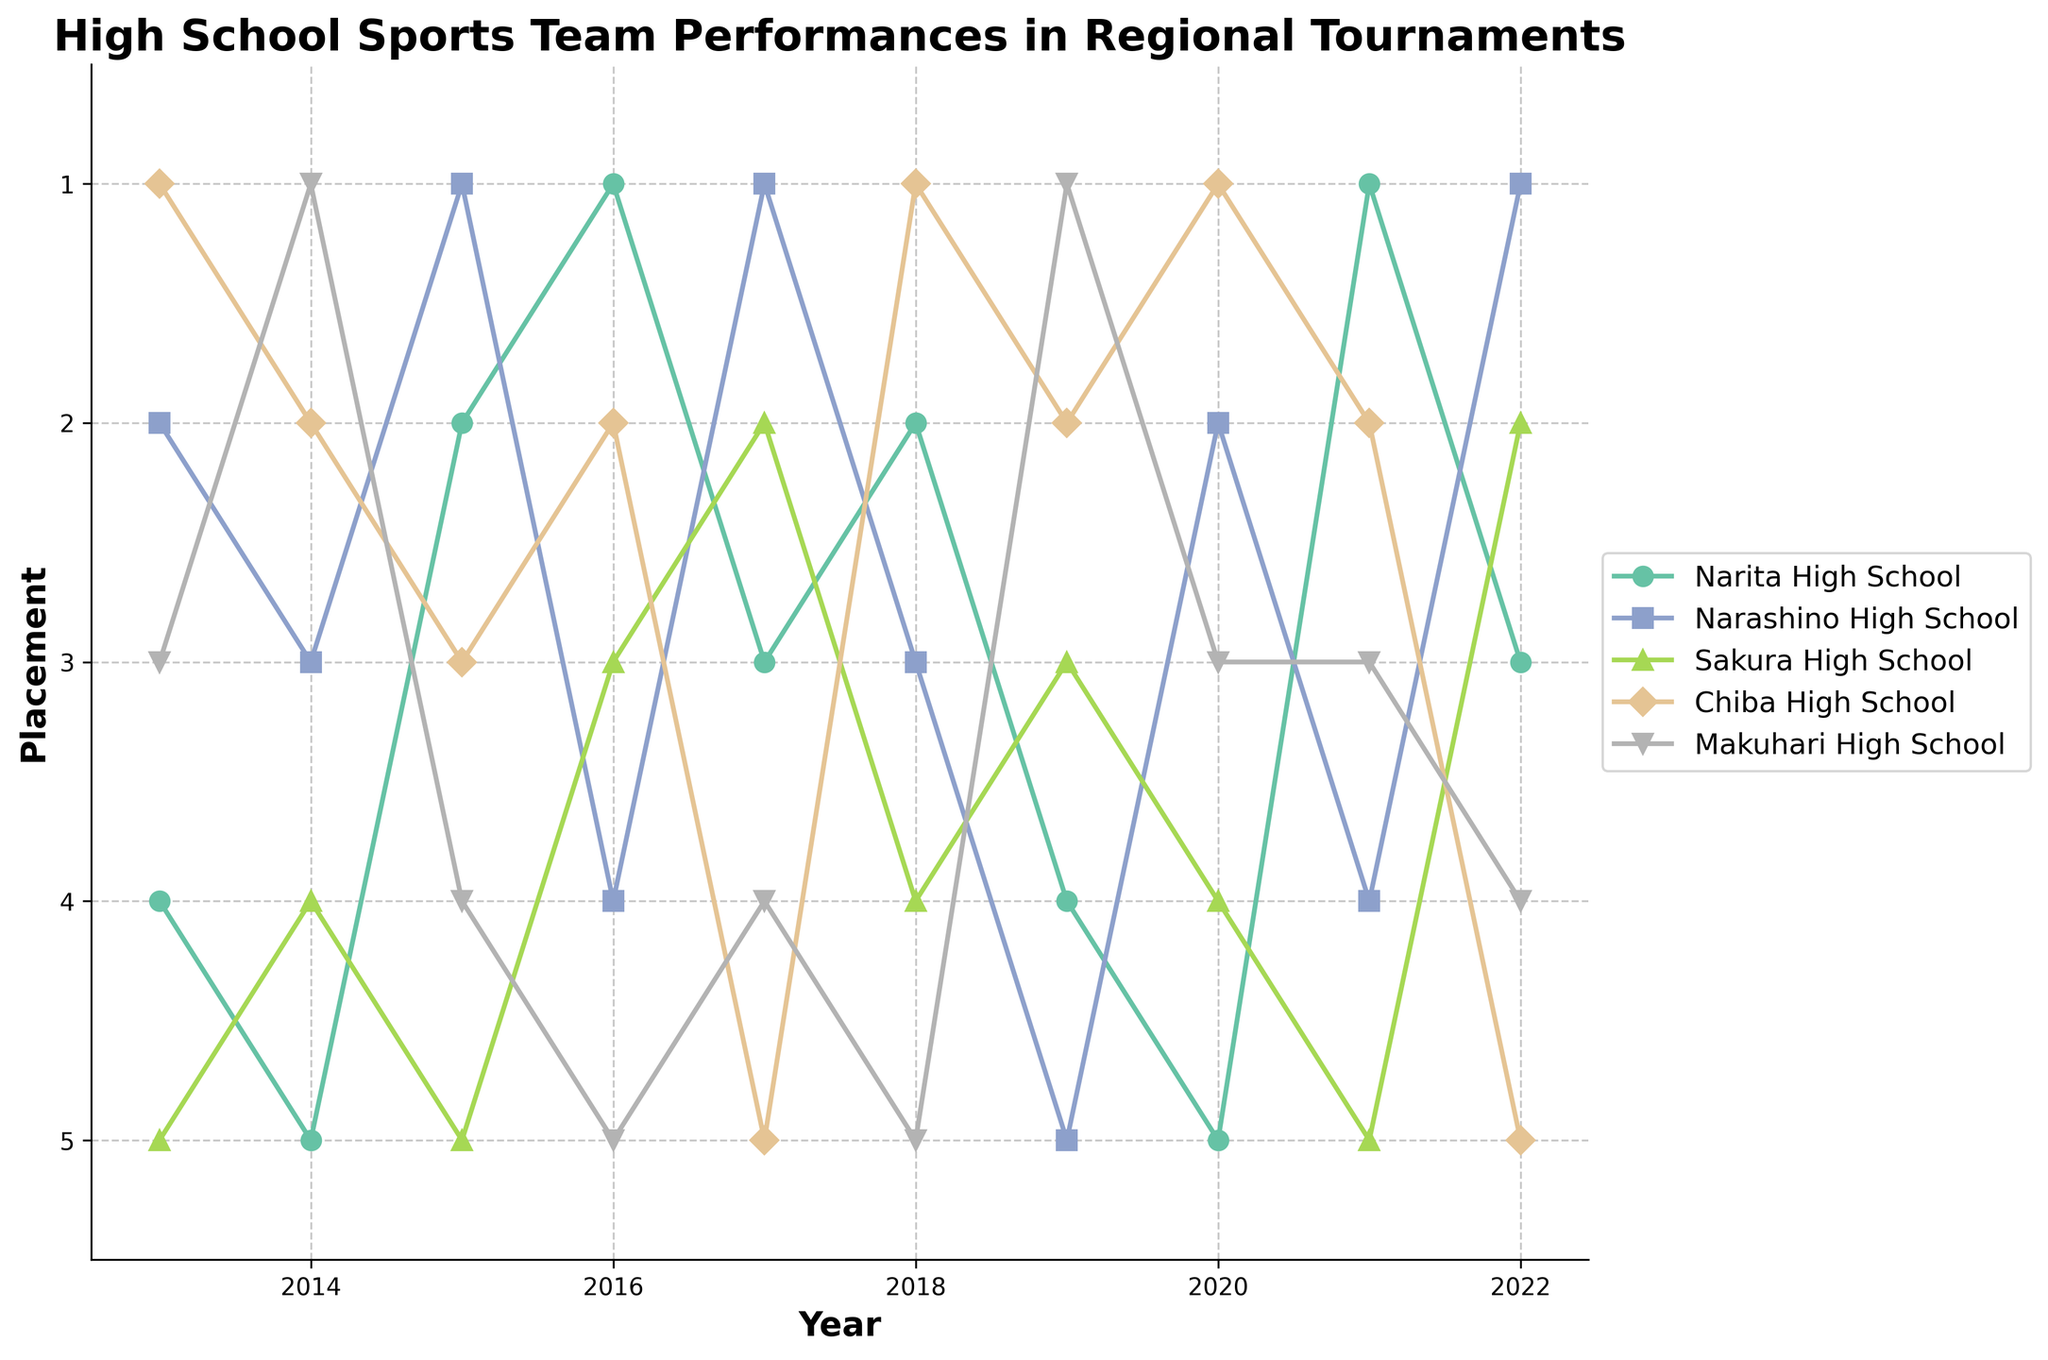What is the title of the plot? The title of the plot is placed at the top of the figure and reads "High School Sports Team Performances in Regional Tournaments".
Answer: High School Sports Team Performances in Regional Tournaments Which school had the best performance in 2016? The best performance is indicated by the lowest placement number. In 2016, Narita High School has a placement of 1, which is the best performance.
Answer: Narita High School What was the trend in the performance of Narita High School from 2013 to 2022? Observing the line representing Narita High School, it starts at 4th place in 2013, goes through ups and downs, peaking at 1st in 2016 and 2021, and ends at 3rd in 2022. This indicates variability in performance.
Answer: Variable performance with peaks in 2016 and 2021 Which year did Chiba High School rank 5th place? By following the line for Chiba High School, it ranks 5th in 2017 and 2022.
Answer: 2017 and 2022 What is the median placement for Narita High School over the decade? Collecting the data for Narita High School (4, 5, 2, 1, 3, 2, 4, 5, 1, 3), sorting them (1, 1, 2, 2, 3, 3, 4, 4, 5, 5), the median is the average of the 5th and 6th values which are both 3.
Answer: 3 In which year did Narashino High School reach 1st place? The line for Narashino High School shows the school reached 1st place in 2015, 2017, and 2022.
Answer: 2015, 2017, and 2022 Compare the performance trends of Narita High School and Narashino High School. Narita High School shows a variable trend with peaks in 2016 and 2021, while Narashino High School has more consistent top performances, especially reaching 1st place in 2015, 2017, and 2022.
Answer: Narita High: Variable with peaks; Narashino High: More consistent with top performances What is the overall trend for Makuhari High School from 2013 to 2022? The trend for Makuhari High School starts at 3rd in 2013, fluctuates, reaches 1st in 2019, and trends downwards ending at 4th in 2022.
Answer: Fluctuating, peaks in 2019, downward towards 2022 How many times did Sakura High School finish 5th? The plot shows Sakura High School finishing 5th in 2013, 2015, 2021, and 2022. This indicates 4 times.
Answer: 4 